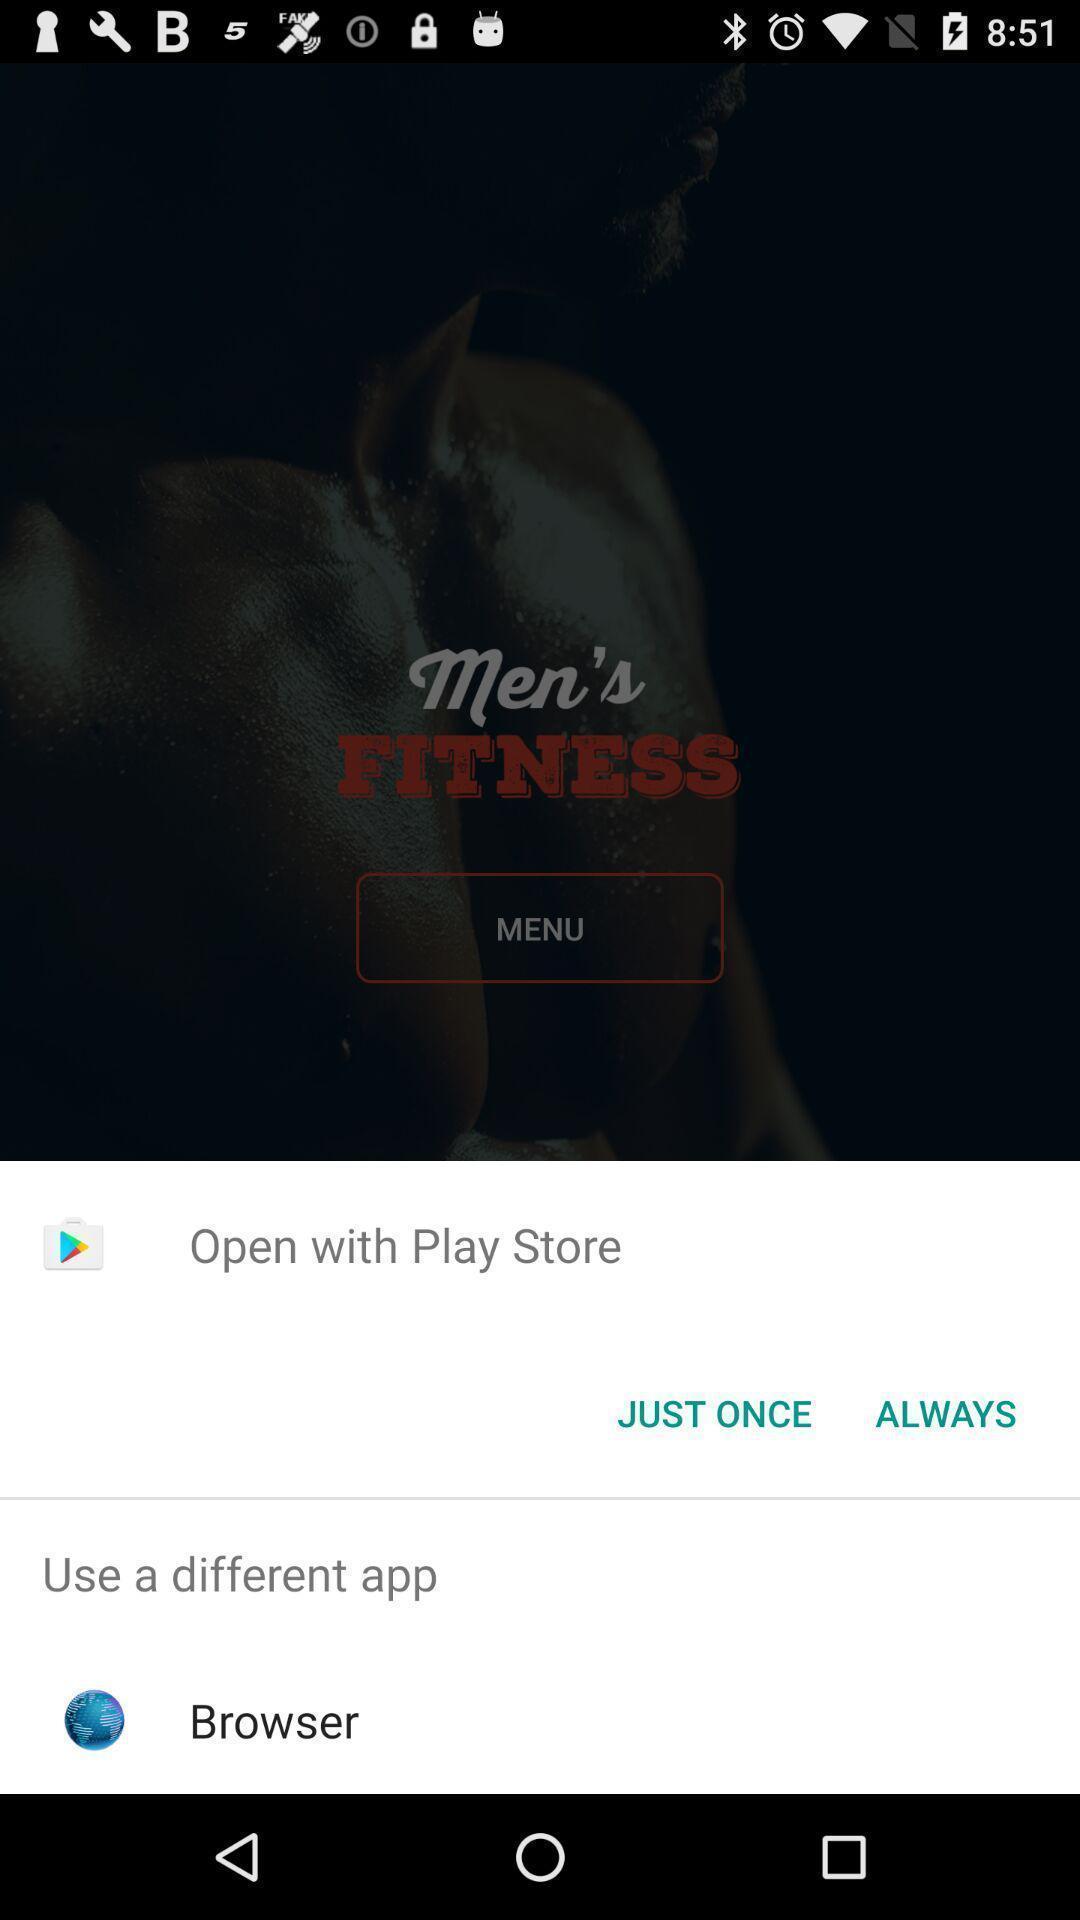What is the overall content of this screenshot? Screen display various options to open with. 